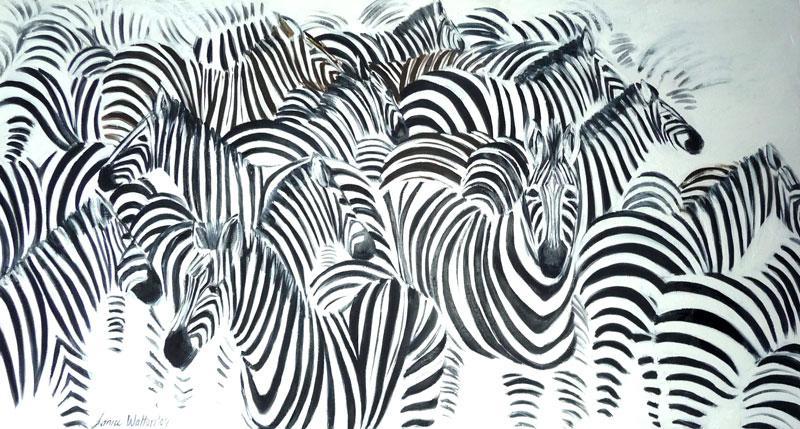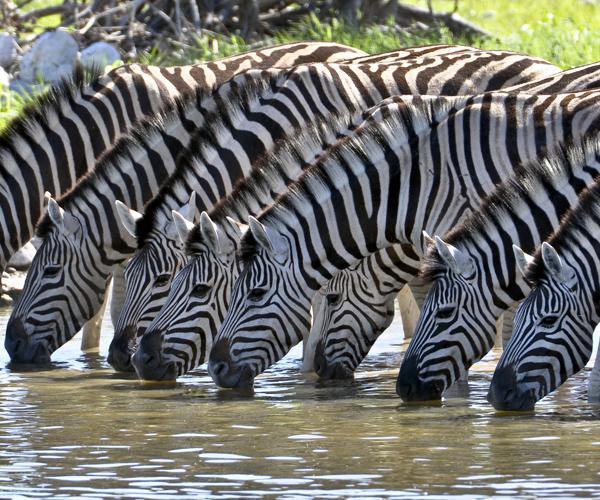The first image is the image on the left, the second image is the image on the right. Analyze the images presented: Is the assertion "The right image shows zebras lined up with heads bent to the water, and the left image shows zebras en masse with nothing else in the picture." valid? Answer yes or no. Yes. 